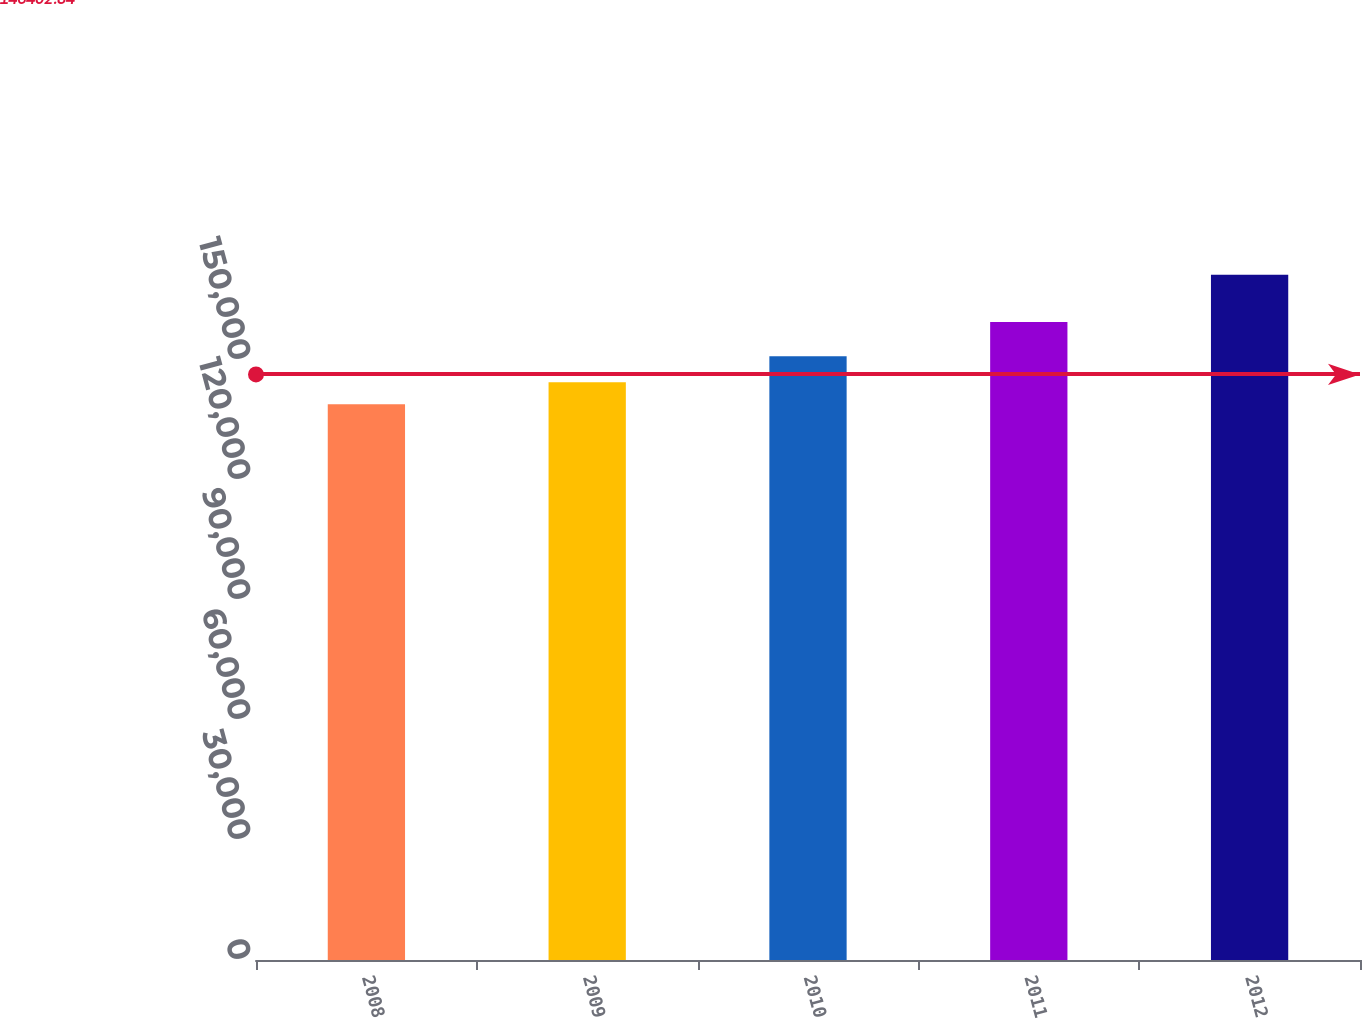Convert chart. <chart><loc_0><loc_0><loc_500><loc_500><bar_chart><fcel>2008<fcel>2009<fcel>2010<fcel>2011<fcel>2012<nl><fcel>138942<fcel>144468<fcel>150929<fcel>159494<fcel>171302<nl></chart> 